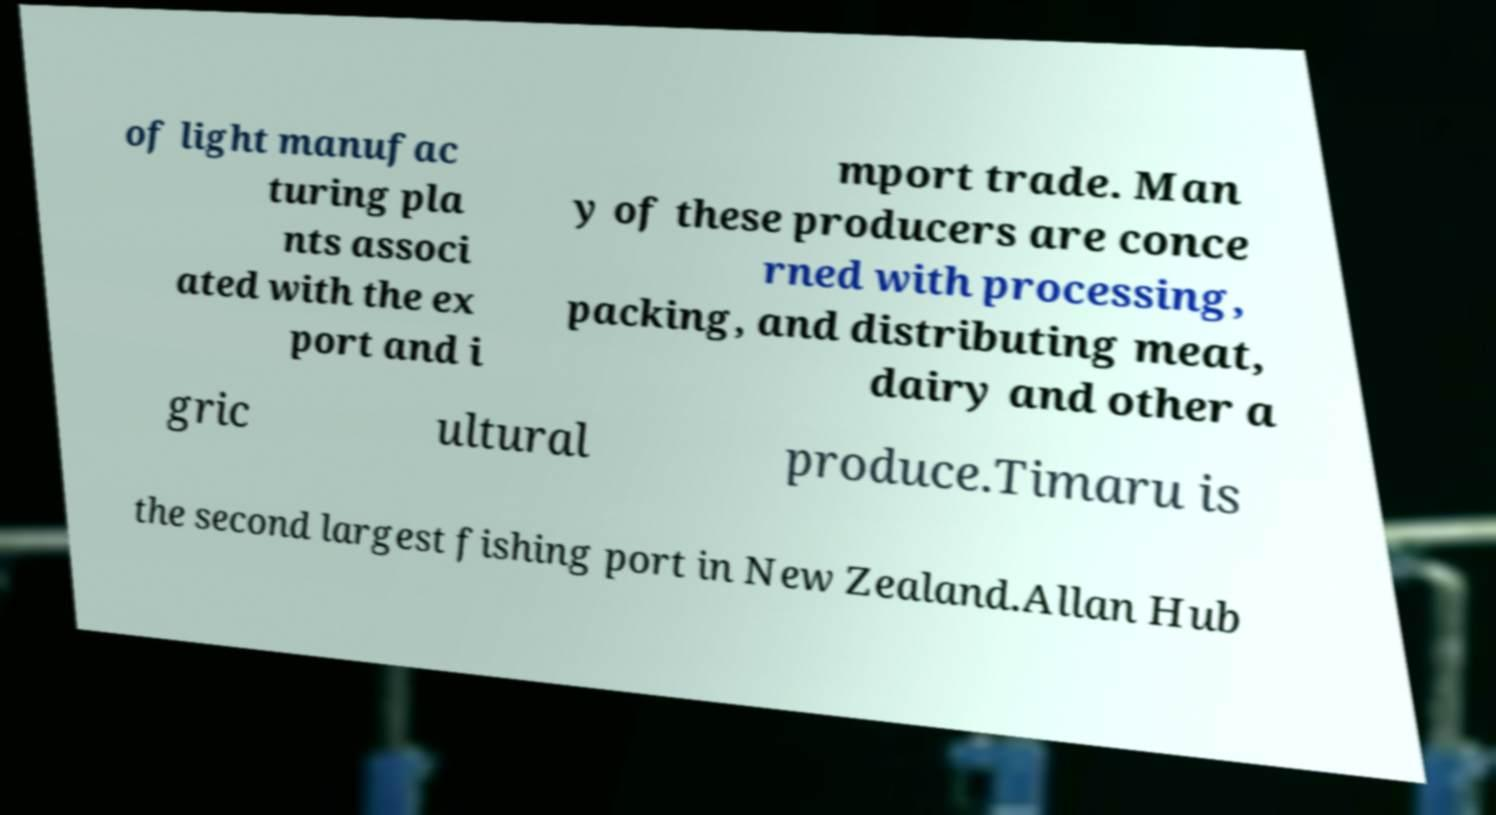Could you extract and type out the text from this image? of light manufac turing pla nts associ ated with the ex port and i mport trade. Man y of these producers are conce rned with processing, packing, and distributing meat, dairy and other a gric ultural produce.Timaru is the second largest fishing port in New Zealand.Allan Hub 